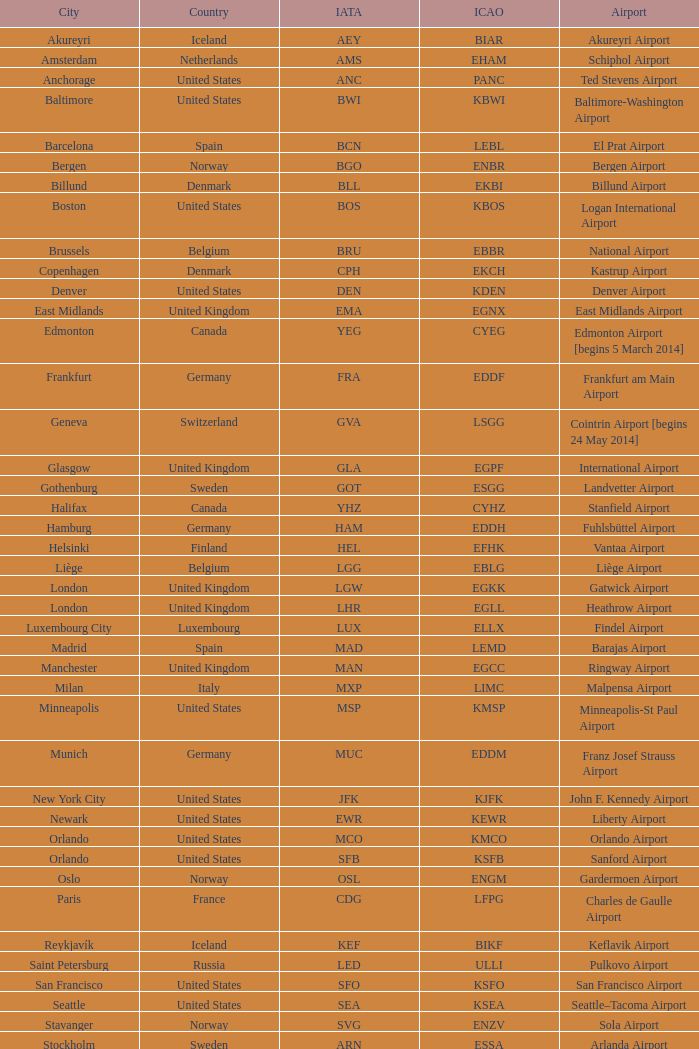Which airport possesses the icao identifier ksea? Seattle–Tacoma Airport. 